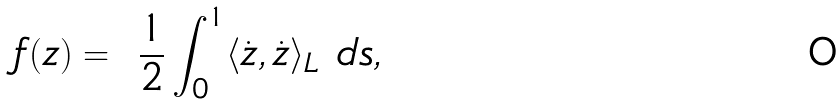Convert formula to latex. <formula><loc_0><loc_0><loc_500><loc_500>f ( z ) = \ \frac { 1 } { 2 } \int _ { 0 } ^ { 1 } \langle \dot { z } , \dot { z } \rangle _ { L } \ d s ,</formula> 